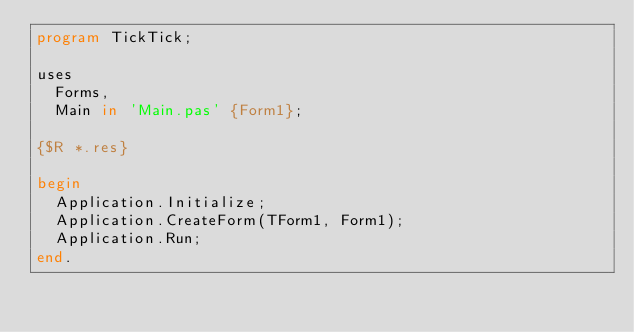Convert code to text. <code><loc_0><loc_0><loc_500><loc_500><_Pascal_>program TickTick;

uses
  Forms,
  Main in 'Main.pas' {Form1};

{$R *.res}

begin
  Application.Initialize;
  Application.CreateForm(TForm1, Form1);
  Application.Run;
end.
</code> 